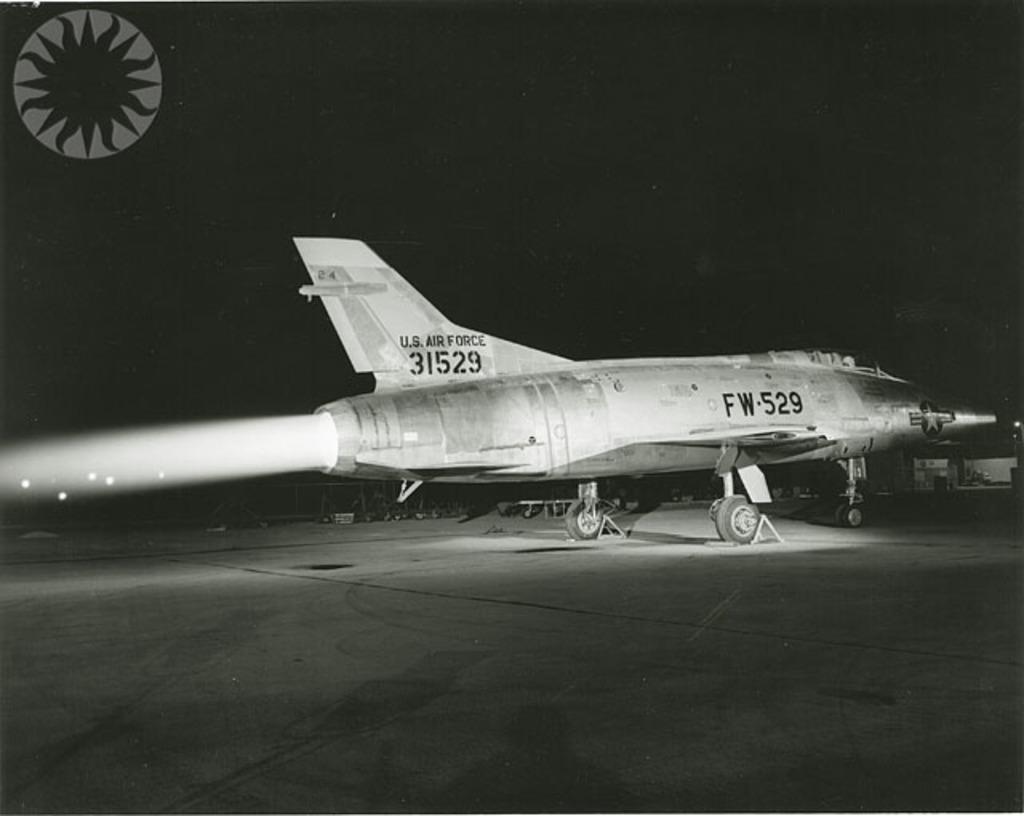What branch is this place with?
Make the answer very short. Air force. What is on the side of the plane?
Give a very brief answer. Fw-529. 